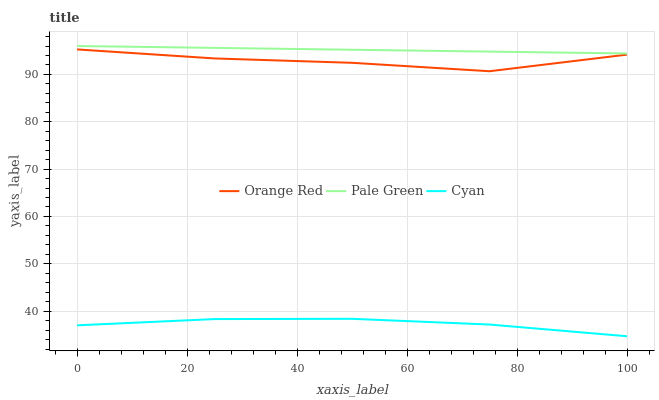Does Cyan have the minimum area under the curve?
Answer yes or no. Yes. Does Pale Green have the maximum area under the curve?
Answer yes or no. Yes. Does Orange Red have the minimum area under the curve?
Answer yes or no. No. Does Orange Red have the maximum area under the curve?
Answer yes or no. No. Is Pale Green the smoothest?
Answer yes or no. Yes. Is Orange Red the roughest?
Answer yes or no. Yes. Is Orange Red the smoothest?
Answer yes or no. No. Is Pale Green the roughest?
Answer yes or no. No. Does Cyan have the lowest value?
Answer yes or no. Yes. Does Orange Red have the lowest value?
Answer yes or no. No. Does Pale Green have the highest value?
Answer yes or no. Yes. Does Orange Red have the highest value?
Answer yes or no. No. Is Cyan less than Pale Green?
Answer yes or no. Yes. Is Pale Green greater than Cyan?
Answer yes or no. Yes. Does Cyan intersect Pale Green?
Answer yes or no. No. 